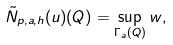<formula> <loc_0><loc_0><loc_500><loc_500>\tilde { N } _ { p , a , h } ( u ) ( Q ) = \sup _ { \Gamma _ { a } ( Q ) } w ,</formula> 